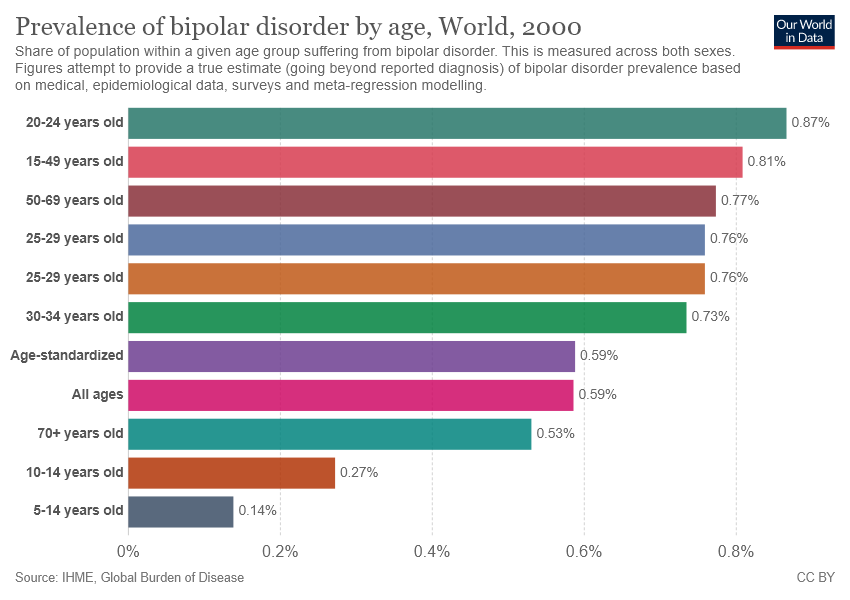Point out several critical features in this image. The difference between the maximum and mode of the bipolar disorder prevalence across all age groups is 0.11. It is a bar chart. 